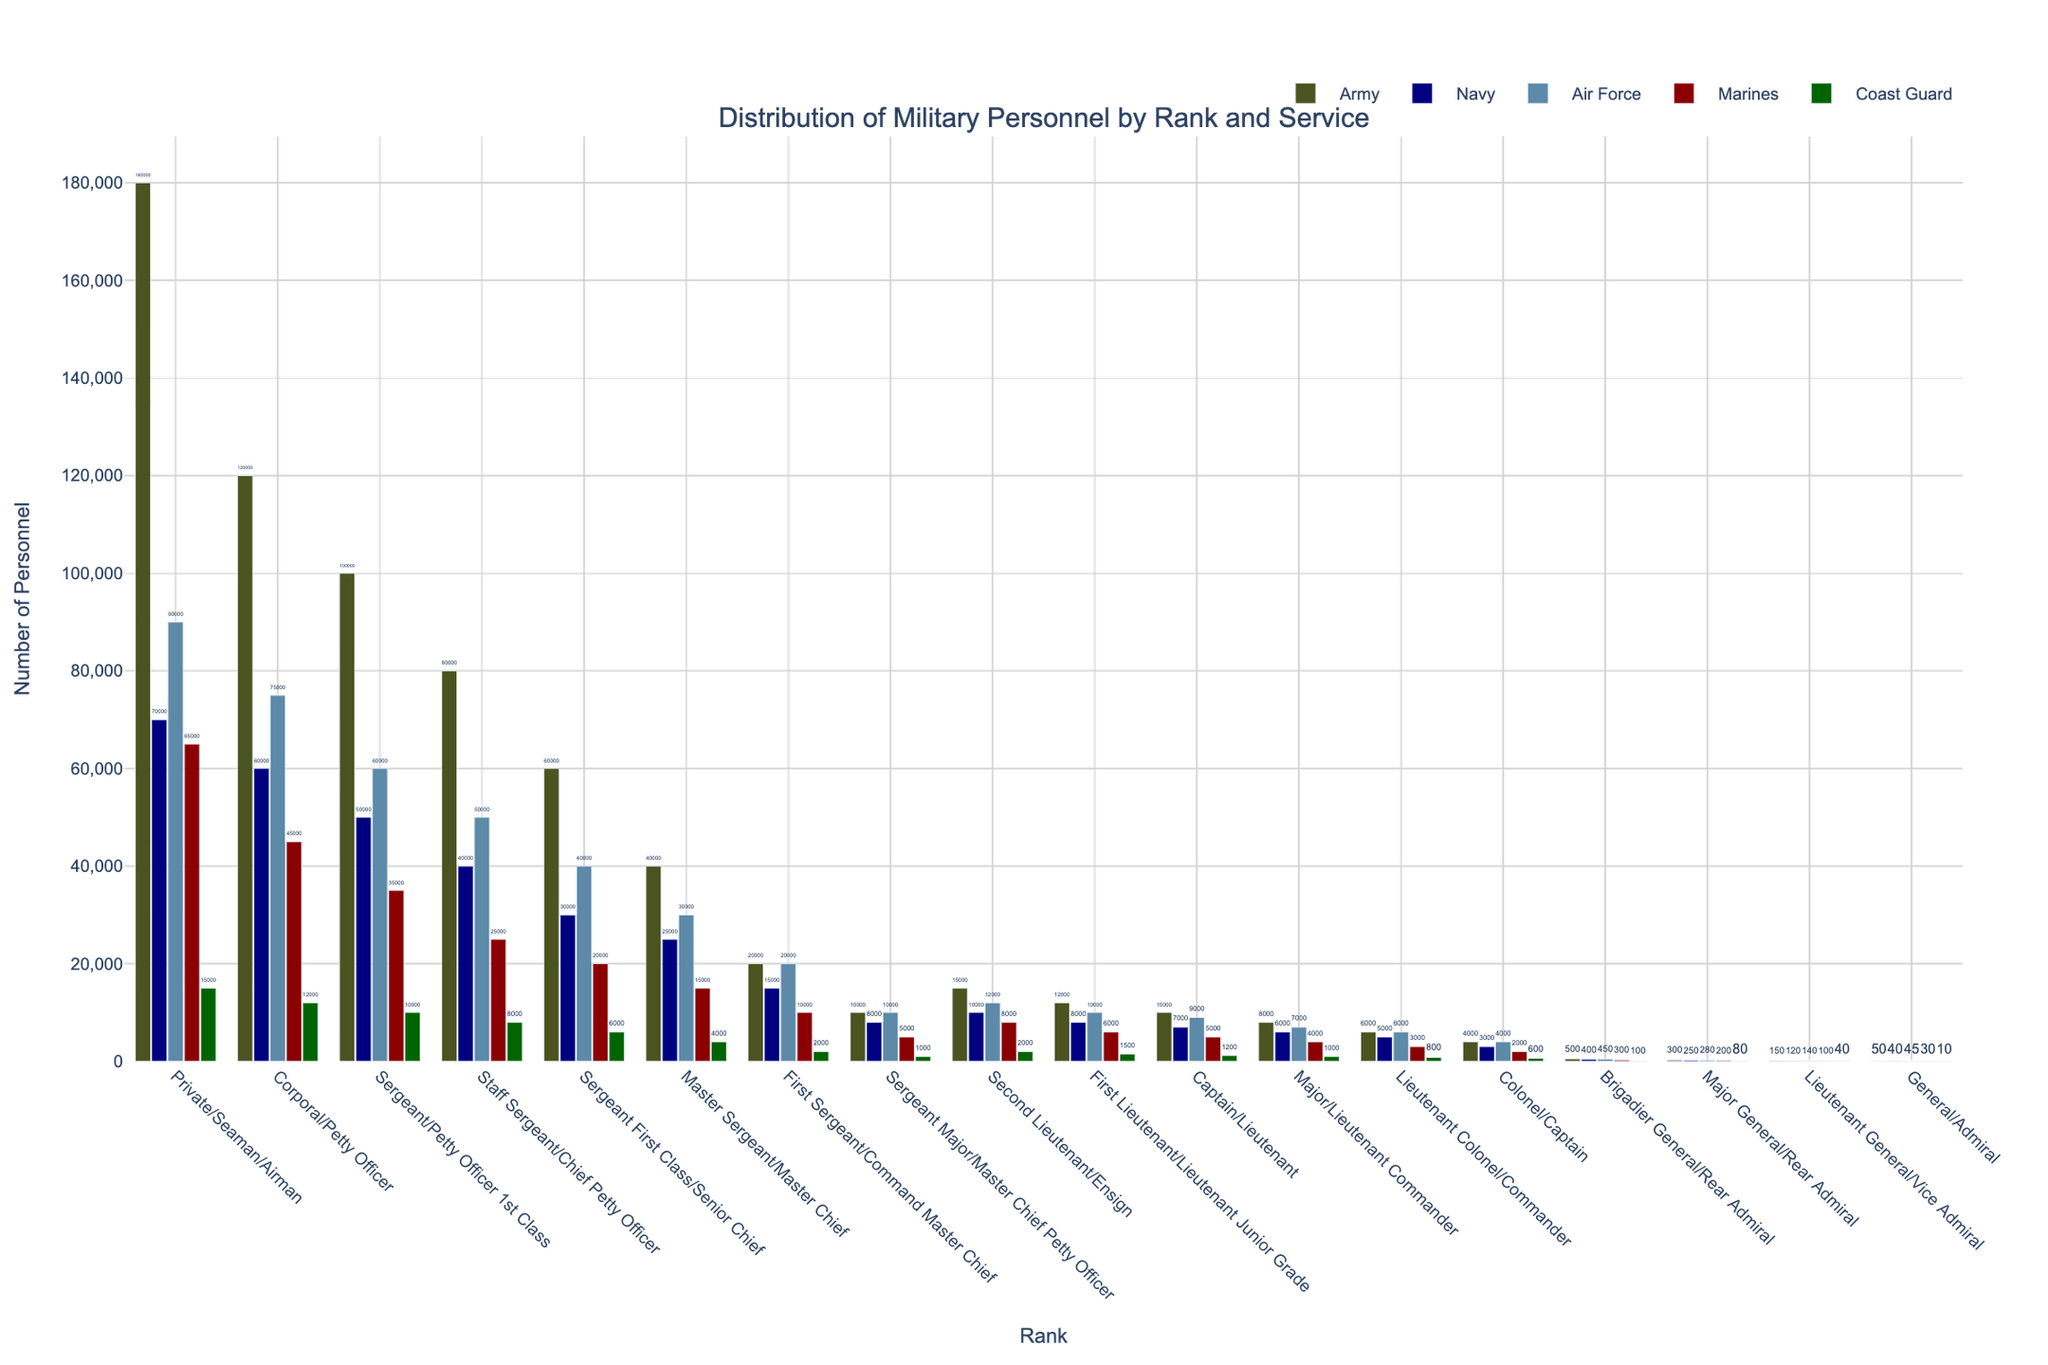Which rank has the highest number of personnel in the Army? By visually inspecting the height of the bars for each rank under the Army, we can see that the "Private/Seaman/Airman" rank has the highest bar indicating the largest number of personnel.
Answer: Private/Seaman/Airman Which service has fewer personnel at the rank of Sergeant Major/Master Chief Petty Officer, Navy or Air Force? Compare the bars for the "Navy" and "Air Force" services for the rank of Sergeant Major/Master Chief Petty Officer. The bar for the Navy is slightly shorter than the one for the Air Force.
Answer: Navy How many total personnel are there in the Marines at the ranks of Private/Seaman/Airman and Corporal/Petty Officer combined? Add the number of personnel in the Marines for both these ranks: 65,000 (Private/Seaman/Airman) + 45,000 (Corporal/Petty Officer).
Answer: 110,000 Which service has the greatest number of personnel at the rank of Brigadier General/Rear Admiral? By comparing the height of the bars across all services for the rank of Brigadier General/Rear Admiral, the Army has the highest bar.
Answer: Army How does the number of Coast Guard personnel at the rank of Major/Lieutenant Commander compare to that of the Army? Observe the bars for the Major/Lieutenant Commander rank for both the Coast Guard and the Army. The bar for the Army is significantly taller than that for the Coast Guard.
Answer: Army has more Calculate the average number of personnel in the Navy across all ranks. Sum the Navy personnel for all ranks and divide by the number of ranks: (70,000 + 60,000 + 50,000 + 40,000 + 30,000 + 25,000 + 15,000 + 8,000 + 10,000 + 8,000 + 7,000 + 6,000 + 5,000 + 3,000 + 400 + 250 + 120 + 40) / 18 = 21,868.89.
Answer: 21,869 How many more personnel are there in the rank of Sergeant First Class/Senior Chief in the Air Force compared to the Marines? Subtract the number of Marines personnel in this rank from that of the Air Force: 40,000 (Air Force) - 20,000 (Marines).
Answer: 20,000 Which rank has an equal number of personnel in both the Army and the Air Force? Visually inspect for bars of the same height in both services; the rank "Captain/Lieutenant" has bars of the same height.
Answer: Captain/Lieutenant Is the number of personnel in the Marines at the rank of Lieutenant Colonel/Commander greater than the number in the Navy at the same rank? Compare the heights of the bars for Lieutenant Colonel/Commander for the Marines and the Navy. The Marine bar is slightly taller than the Navy bar.
Answer: Yes What's the median value of personnel in the Army ranks? Arrange the Army values in ascending order and find the middle value in the list (or the average of the two middle values for an even number of ranks). Army personnel values: 50, 150, 300, 400, 600, 1000, 2000, 3000, 4000, 6000, 8000, 10000, 20000, 40000, 60000, 80000, 100000, 120000, 180000. The 10th and 11th values (6000 and 8000) average to get median: (6000 + 8000) / 2.
Answer: 7,000 